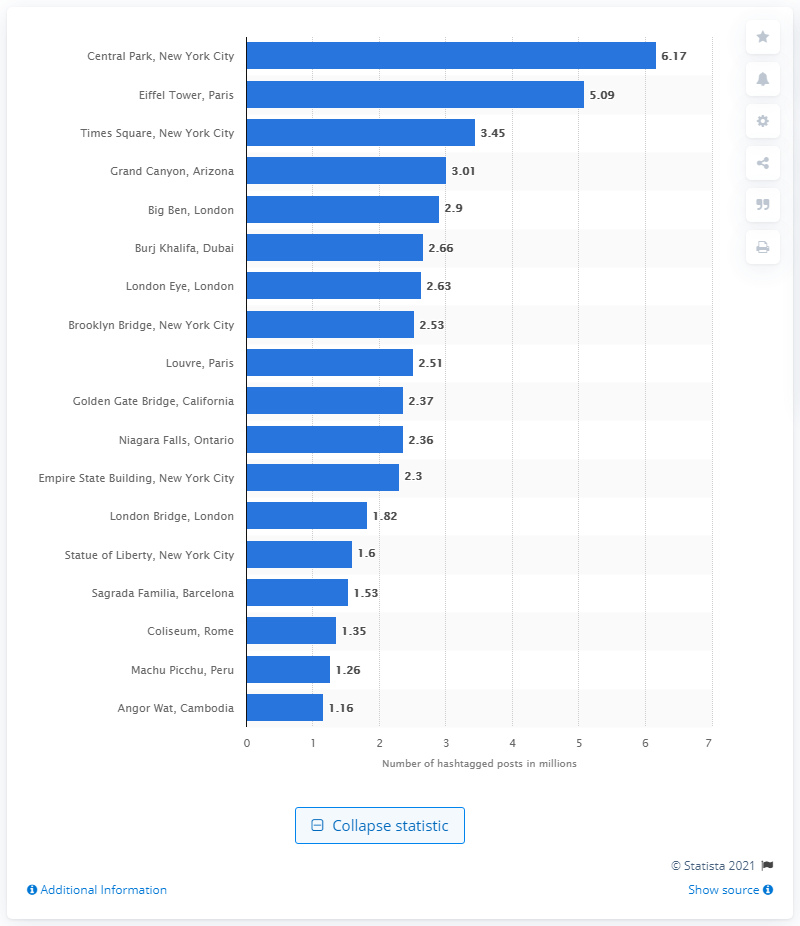Indicate a few pertinent items in this graphic. Six people mentioned Central Park on Instagram. 